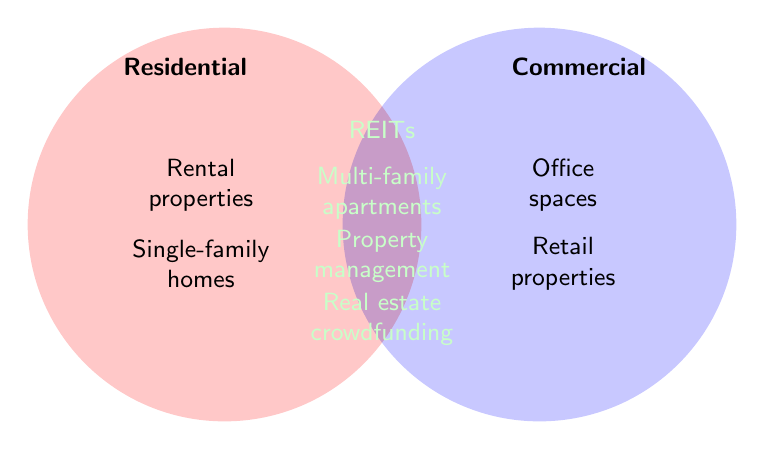How many types of properties fall under the Residential category only? Look at the left circle labeled "Residential" and count the property types listed inside it.
Answer: 2 Which category includes REITs? Find the REITs label and see which part of the Venn Diagram it is located in.
Answer: Both What are the property types exclusive to the Commercial category? Identify the specific property types listed only within the right circle labeled "Commercial".
Answer: Office spaces, Retail properties How many property types are shared between Residential and Commercial categories? Check the overlapping section of the Venn Diagram to see how many items are listed there.
Answer: 4 Are Single-family homes and Retail properties part of the same category? Look at where Single-family homes and Retail properties are located in the Venn Diagram and see if they share the same section.
Answer: No Which category or categories include Property management? Locate Property management in the Venn Diagram and check whether it is in the overlapping area or in one of the specific category circles.
Answer: Both Which category has more individual property types listed, Residential or Commercial? Count the number of property types in the Residential circle and compare it with the number of property types in the Commercial circle.
Answer: Commercial What type of property is listed last under the shared category (Both)? Identify the overlapping section and find the last property type listed there.
Answer: Real estate crowdfunding Is there any type of property that appears in all three categories, Residential, Commercial, and Both? Check the Venn Diagram to see if any property type is present in all three sections.
Answer: No Name a property type that is part of the Residential but not shared with Commercial. Look at the Residential circle and find a property type that is not in the overlapping area.
Answer: Rental properties 